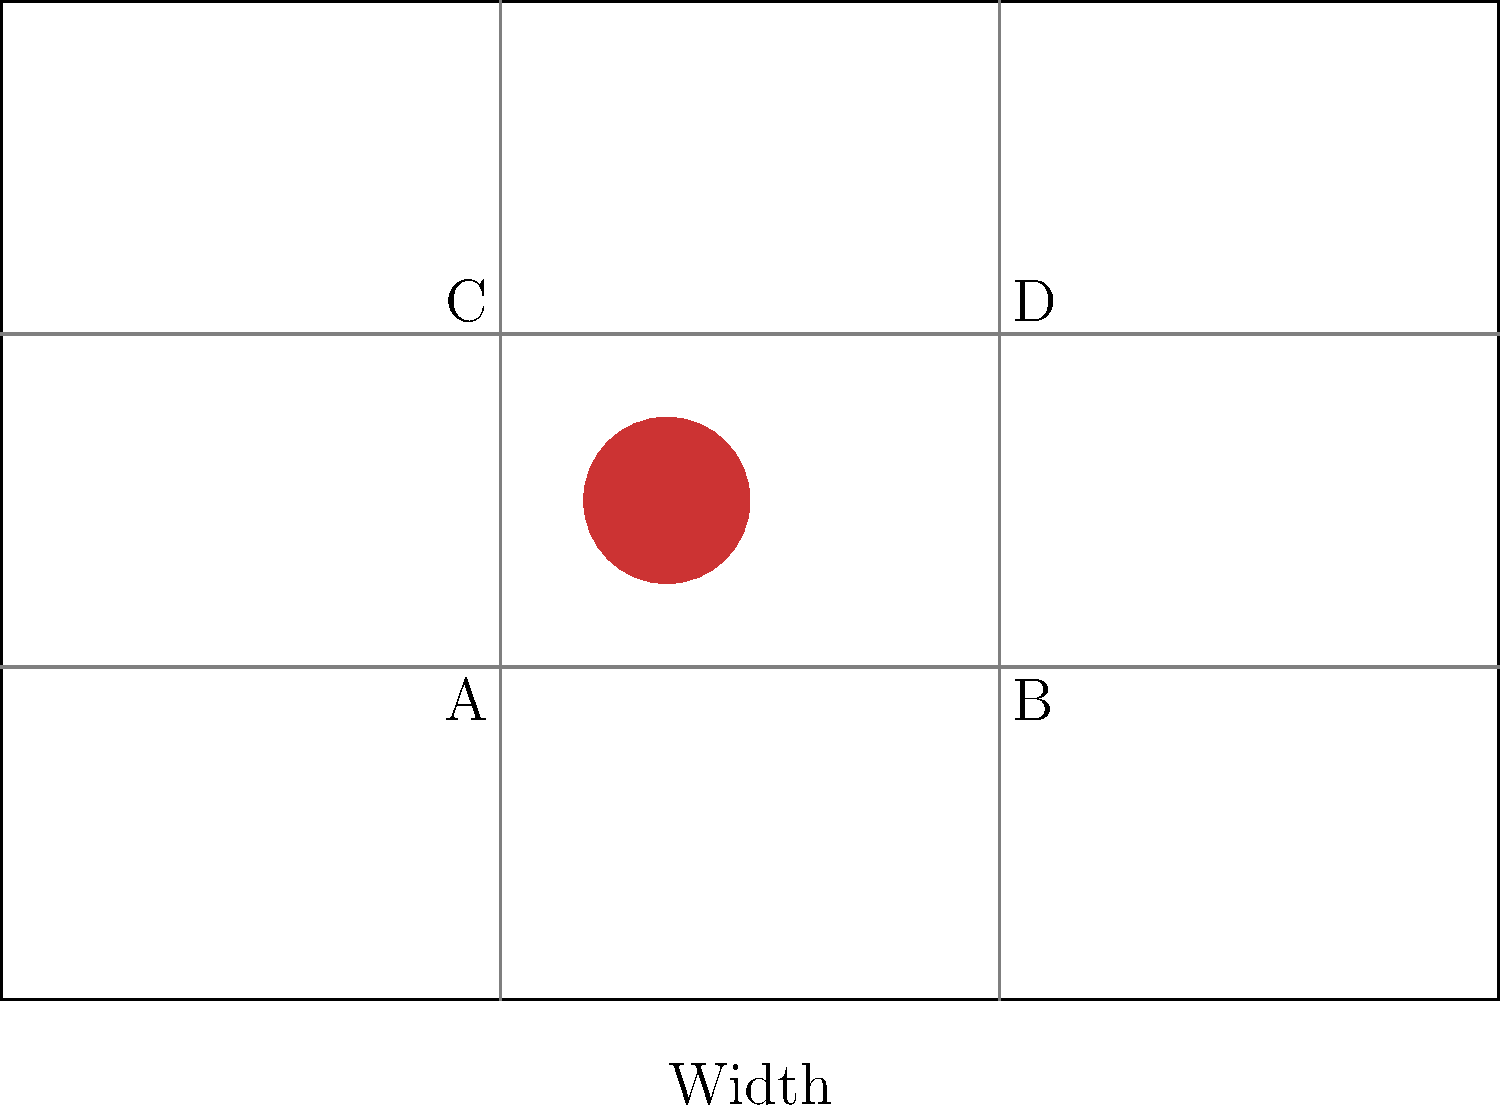In the frame above, which rule of thirds intersection point is closest to the subject, and how might this placement affect the viewer's perception of the scene? To answer this question, we need to follow these steps:

1. Understand the rule of thirds: The rule of thirds divides a frame into a 3x3 grid, creating four intersection points.

2. Identify the intersection points: In the diagram, these are labeled A, B, C, and D.

3. Locate the subject: The subject is represented by the red circle in the frame.

4. Determine the closest intersection point: The subject appears to be closest to point A (3,2).

5. Analyze the effect of this placement:
   a) Left-side placement creates visual tension, implying movement or direction.
   b) Lower placement can make the subject appear more grounded or stable.
   c) Proximity to the intersection point draws the viewer's eye naturally.
   d) Space to the right allows for implied motion or narrative progression.

6. Consider the cinematic impact: This placement can create a sense of anticipation or introduce the subject subtly, allowing room for other elements in the frame.
Answer: Point A; creates tension, implies movement, and draws attention while leaving space for narrative development. 